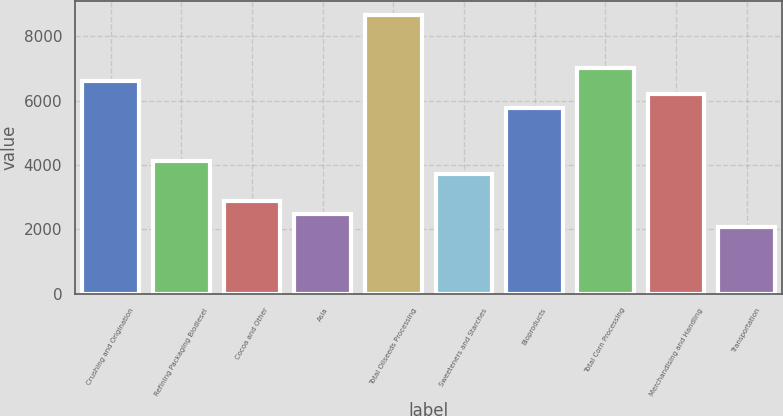Convert chart to OTSL. <chart><loc_0><loc_0><loc_500><loc_500><bar_chart><fcel>Crushing and Origination<fcel>Refining Packaging Biodiesel<fcel>Cocoa and Other<fcel>Asia<fcel>Total Oilseeds Processing<fcel>Sweeteners and Starches<fcel>Bioproducts<fcel>Total Corn Processing<fcel>Merchandising and Handling<fcel>Transportation<nl><fcel>6609<fcel>4131<fcel>2892<fcel>2479<fcel>8674<fcel>3718<fcel>5783<fcel>7022<fcel>6196<fcel>2066<nl></chart> 